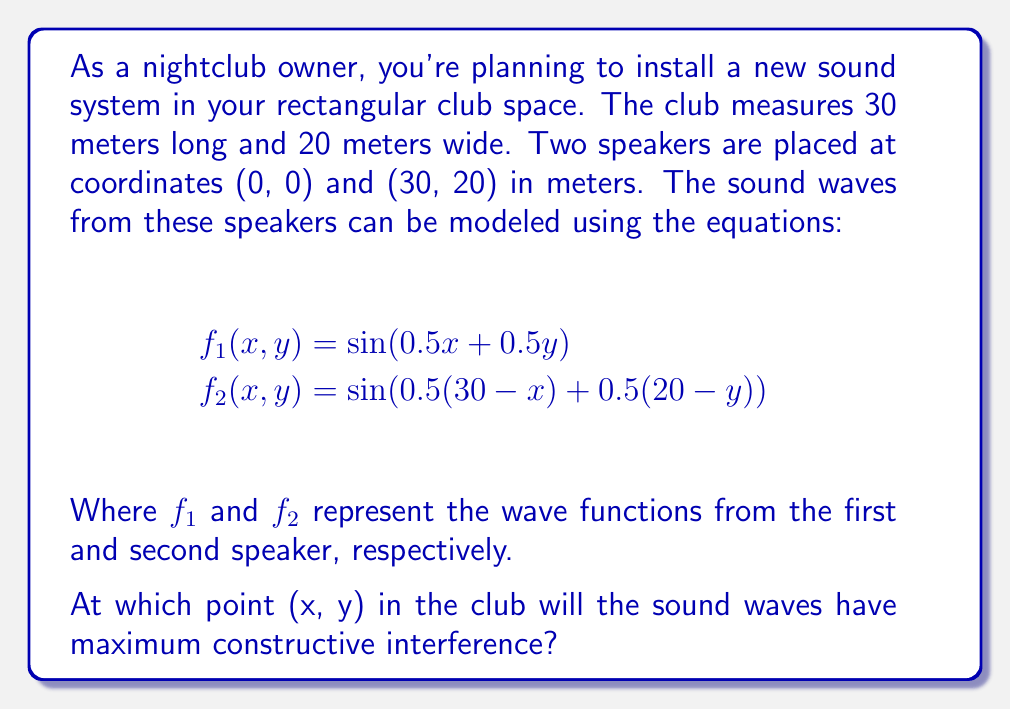Can you solve this math problem? To solve this problem, we need to follow these steps:

1) The total wave function is the sum of the two individual wave functions:
   $$f_{total}(x, y) = f_1(x, y) + f_2(x, y)$$

2) Maximum constructive interference occurs when both waves are in phase, i.e., when their arguments are equal (modulo $2\pi$):
   $$0.5x + 0.5y = 0.5(30-x) + 0.5(20-y) + 2\pi n$$
   where $n$ is an integer.

3) Simplify the equation:
   $$0.5x + 0.5y = 15 - 0.5x + 10 - 0.5y + 2\pi n$$
   $$x + y = 25 - x - y + 4\pi n$$
   $$2x + 2y = 25 + 4\pi n$$

4) Solve for $y$:
   $$y = \frac{25 + 4\pi n - 2x}{2}$$

5) Since we're looking for a point inside the club, $0 \leq x \leq 30$ and $0 \leq y \leq 20$. The smallest non-negative value of $n$ that satisfies these conditions is $n = 0$.

6) With $n = 0$, we have:
   $$y = \frac{25 - 2x}{2}$$

7) This line intersects the club space at (0, 12.5) and (12.5, 0). The midpoint of this line segment will be the point of maximum constructive interference.

8) Calculate the midpoint:
   $$x = \frac{0 + 12.5}{2} = 6.25$$
   $$y = \frac{12.5 + 0}{2} = 6.25$$

Therefore, the point of maximum constructive interference is (6.25, 6.25).
Answer: The point of maximum constructive interference is (6.25, 6.25) meters from the origin. 